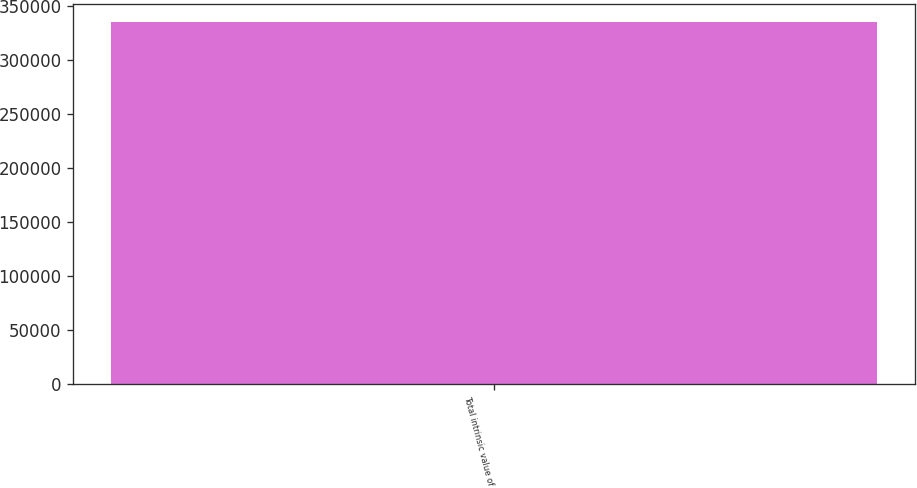<chart> <loc_0><loc_0><loc_500><loc_500><bar_chart><fcel>Total intrinsic value of<nl><fcel>334931<nl></chart> 